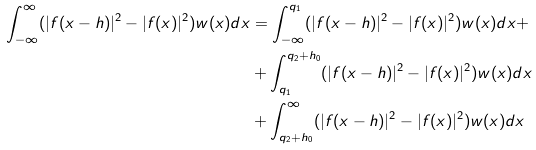<formula> <loc_0><loc_0><loc_500><loc_500>\int _ { - \infty } ^ { \infty } ( | f ( x - h ) | ^ { 2 } - | f ( x ) | ^ { 2 } ) w ( x ) d x & = \int _ { - \infty } ^ { q _ { 1 } } ( | f ( x - h ) | ^ { 2 } - | f ( x ) | ^ { 2 } ) w ( x ) d x + \\ & + \int _ { q _ { 1 } } ^ { q _ { 2 } + h _ { 0 } } ( | f ( x - h ) | ^ { 2 } - | f ( x ) | ^ { 2 } ) w ( x ) d x \\ & + \int _ { q _ { 2 } + h _ { 0 } } ^ { \infty } ( | f ( x - h ) | ^ { 2 } - | f ( x ) | ^ { 2 } ) w ( x ) d x</formula> 